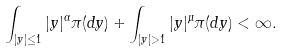<formula> <loc_0><loc_0><loc_500><loc_500>\int _ { | y | \leq 1 } | y | ^ { \alpha } \pi ( d y ) + \int _ { | y | > 1 } | y | ^ { \mu } \pi ( d y ) < \infty .</formula> 